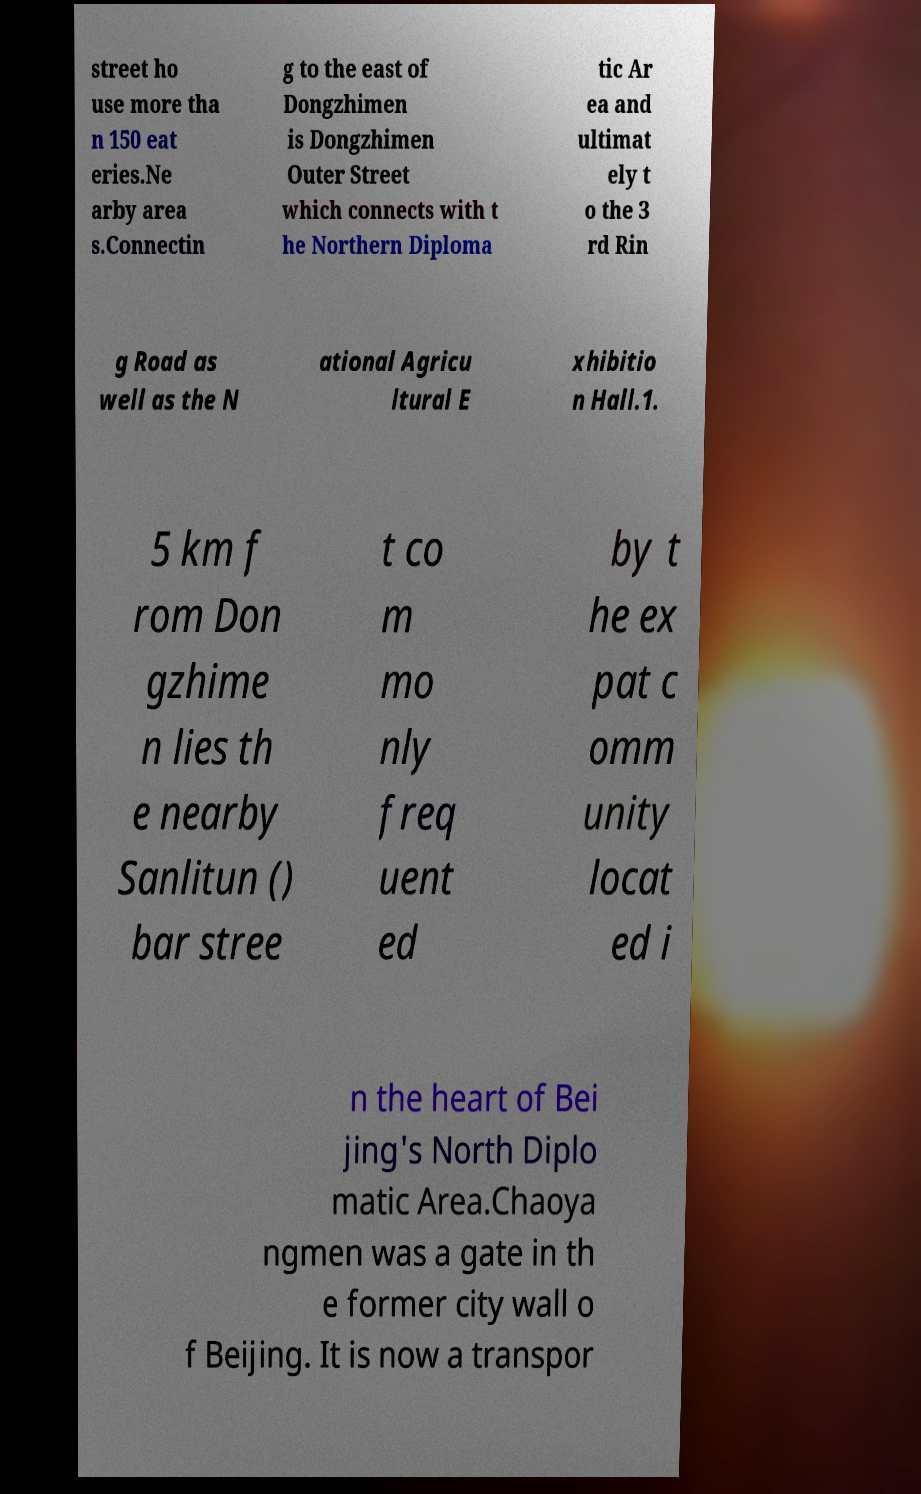There's text embedded in this image that I need extracted. Can you transcribe it verbatim? street ho use more tha n 150 eat eries.Ne arby area s.Connectin g to the east of Dongzhimen is Dongzhimen Outer Street which connects with t he Northern Diploma tic Ar ea and ultimat ely t o the 3 rd Rin g Road as well as the N ational Agricu ltural E xhibitio n Hall.1. 5 km f rom Don gzhime n lies th e nearby Sanlitun () bar stree t co m mo nly freq uent ed by t he ex pat c omm unity locat ed i n the heart of Bei jing's North Diplo matic Area.Chaoya ngmen was a gate in th e former city wall o f Beijing. It is now a transpor 